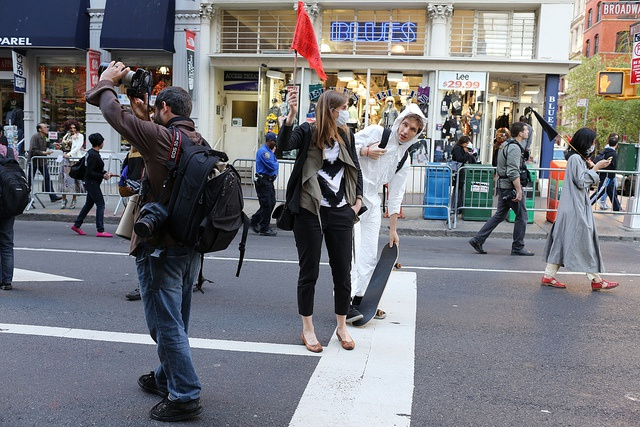Describe the objects in this image and their specific colors. I can see people in navy, black, and gray tones, people in navy, black, gray, darkgray, and lavender tones, people in navy, lightgray, darkgray, black, and gray tones, backpack in navy, black, gray, and darkblue tones, and people in navy, darkgray, black, and gray tones in this image. 